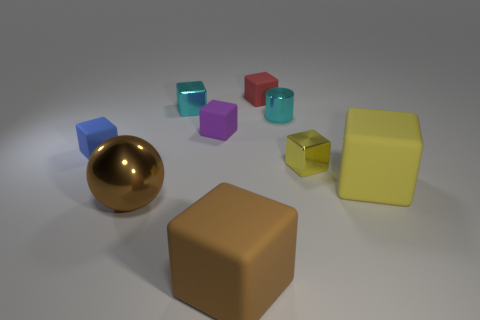There is a rubber thing to the left of the large brown metal object; is its color the same as the ball?
Ensure brevity in your answer.  No. How many cylinders are either brown matte things or blue rubber objects?
Offer a very short reply. 0. There is a yellow block that is left of the big block that is to the right of the small matte object on the right side of the purple thing; how big is it?
Provide a short and direct response. Small. What shape is the red thing that is the same size as the yellow shiny cube?
Offer a terse response. Cube. There is a large yellow rubber thing; what shape is it?
Ensure brevity in your answer.  Cube. Do the tiny object to the left of the large sphere and the small red object have the same material?
Ensure brevity in your answer.  Yes. What size is the yellow thing on the right side of the small object to the right of the shiny cylinder?
Offer a terse response. Large. There is a cube that is to the right of the large brown rubber object and behind the small yellow metal thing; what color is it?
Your response must be concise. Red. What is the material of the red block that is the same size as the yellow metallic object?
Ensure brevity in your answer.  Rubber. What number of other things are there of the same material as the blue object
Your answer should be very brief. 4. 